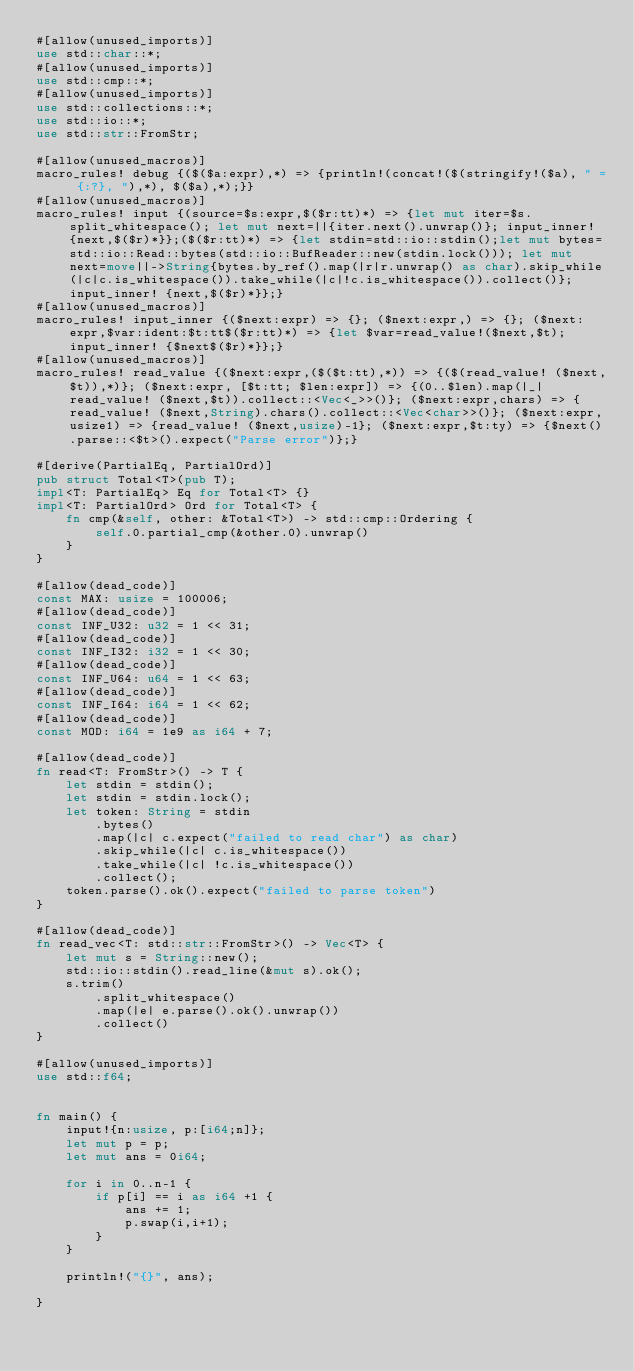Convert code to text. <code><loc_0><loc_0><loc_500><loc_500><_Rust_>#[allow(unused_imports)]
use std::char::*;
#[allow(unused_imports)]
use std::cmp::*;
#[allow(unused_imports)]
use std::collections::*;
use std::io::*;
use std::str::FromStr;

#[allow(unused_macros)]
macro_rules! debug {($($a:expr),*) => {println!(concat!($(stringify!($a), " = {:?}, "),*), $($a),*);}}
#[allow(unused_macros)]
macro_rules! input {(source=$s:expr,$($r:tt)*) => {let mut iter=$s.split_whitespace(); let mut next=||{iter.next().unwrap()}; input_inner! {next,$($r)*}};($($r:tt)*) => {let stdin=std::io::stdin();let mut bytes=std::io::Read::bytes(std::io::BufReader::new(stdin.lock())); let mut next=move||->String{bytes.by_ref().map(|r|r.unwrap() as char).skip_while(|c|c.is_whitespace()).take_while(|c|!c.is_whitespace()).collect()}; input_inner! {next,$($r)*}};}
#[allow(unused_macros)]
macro_rules! input_inner {($next:expr) => {}; ($next:expr,) => {}; ($next:expr,$var:ident:$t:tt$($r:tt)*) => {let $var=read_value!($next,$t); input_inner! {$next$($r)*}};}
#[allow(unused_macros)]
macro_rules! read_value {($next:expr,($($t:tt),*)) => {($(read_value! ($next,$t)),*)}; ($next:expr, [$t:tt; $len:expr]) => {(0..$len).map(|_|read_value! ($next,$t)).collect::<Vec<_>>()}; ($next:expr,chars) => {read_value! ($next,String).chars().collect::<Vec<char>>()}; ($next:expr,usize1) => {read_value! ($next,usize)-1}; ($next:expr,$t:ty) => {$next().parse::<$t>().expect("Parse error")};}

#[derive(PartialEq, PartialOrd)]
pub struct Total<T>(pub T);
impl<T: PartialEq> Eq for Total<T> {}
impl<T: PartialOrd> Ord for Total<T> {
    fn cmp(&self, other: &Total<T>) -> std::cmp::Ordering {
        self.0.partial_cmp(&other.0).unwrap()
    }
}

#[allow(dead_code)]
const MAX: usize = 100006;
#[allow(dead_code)]
const INF_U32: u32 = 1 << 31;
#[allow(dead_code)]
const INF_I32: i32 = 1 << 30;
#[allow(dead_code)]
const INF_U64: u64 = 1 << 63;
#[allow(dead_code)]
const INF_I64: i64 = 1 << 62;
#[allow(dead_code)]
const MOD: i64 = 1e9 as i64 + 7;

#[allow(dead_code)]
fn read<T: FromStr>() -> T {
    let stdin = stdin();
    let stdin = stdin.lock();
    let token: String = stdin
        .bytes()
        .map(|c| c.expect("failed to read char") as char)
        .skip_while(|c| c.is_whitespace())
        .take_while(|c| !c.is_whitespace())
        .collect();
    token.parse().ok().expect("failed to parse token")
}

#[allow(dead_code)]
fn read_vec<T: std::str::FromStr>() -> Vec<T> {
    let mut s = String::new();
    std::io::stdin().read_line(&mut s).ok();
    s.trim()
        .split_whitespace()
        .map(|e| e.parse().ok().unwrap())
        .collect()
}

#[allow(unused_imports)]
use std::f64;


fn main() {
    input!{n:usize, p:[i64;n]};
    let mut p = p;
    let mut ans = 0i64;

    for i in 0..n-1 {
        if p[i] == i as i64 +1 {
            ans += 1;
            p.swap(i,i+1);
        }
    }

    println!("{}", ans);

}</code> 